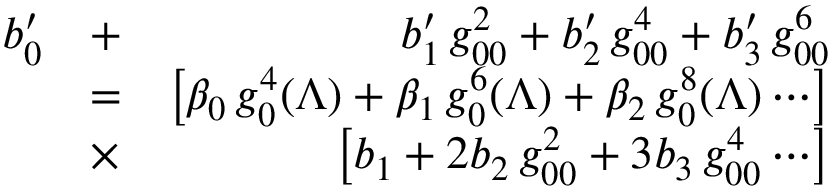Convert formula to latex. <formula><loc_0><loc_0><loc_500><loc_500>\begin{array} { r l r } { b _ { 0 } ^ { \prime } } & { + } & { b _ { 1 } ^ { \prime } \, g _ { 0 0 } ^ { 2 } + b _ { 2 } ^ { \prime } \, g _ { 0 0 } ^ { 4 } + b _ { 3 } ^ { \prime } \, g _ { 0 0 } ^ { 6 } } \\ & { = } & { \left [ \beta _ { 0 } \, g _ { 0 } ^ { 4 } ( \Lambda ) + \beta _ { 1 } \, g _ { 0 } ^ { 6 } ( \Lambda ) + \beta _ { 2 } \, g _ { 0 } ^ { 8 } ( \Lambda ) \cdots \right ] } \\ & { \times } & { \left [ b _ { 1 } + 2 b _ { 2 } \, g _ { 0 0 } ^ { 2 } + 3 b _ { 3 } \, g _ { 0 0 } ^ { 4 } \cdots \right ] } \end{array}</formula> 